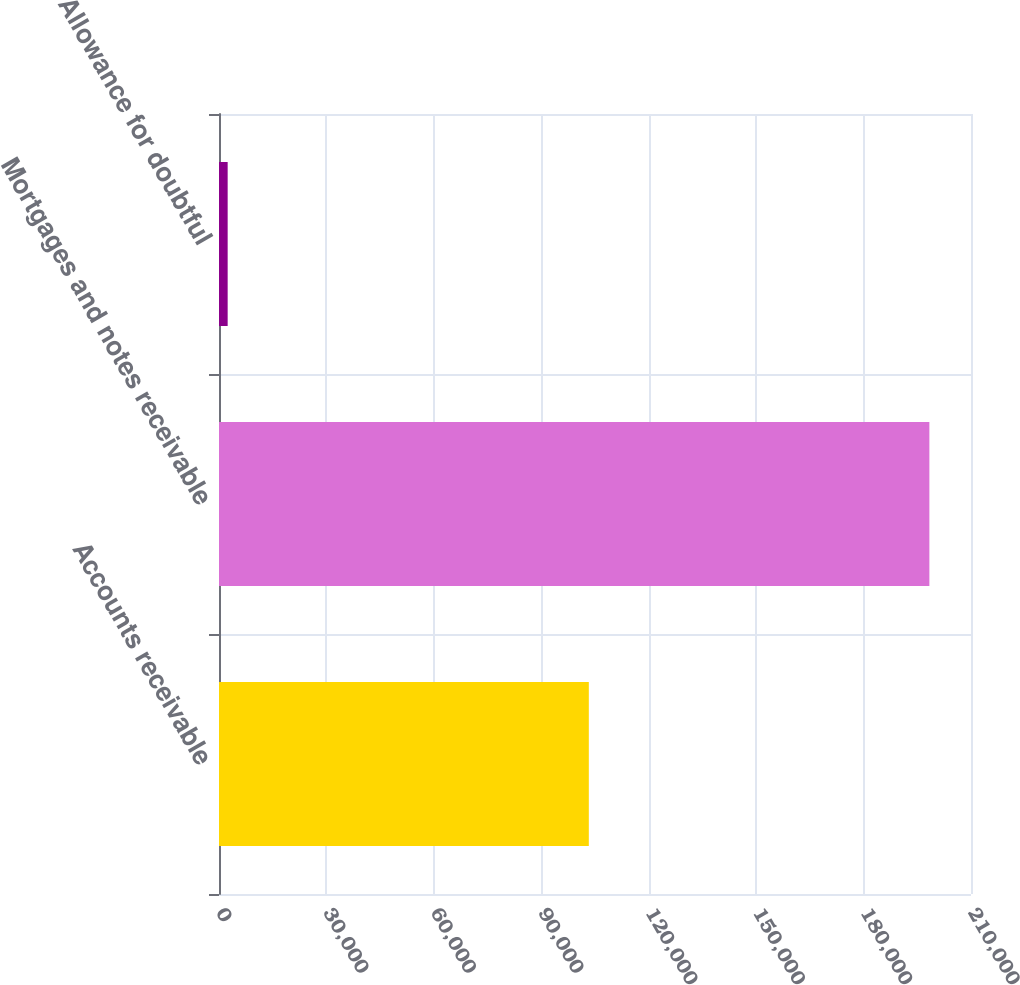<chart> <loc_0><loc_0><loc_500><loc_500><bar_chart><fcel>Accounts receivable<fcel>Mortgages and notes receivable<fcel>Allowance for doubtful<nl><fcel>103275<fcel>198376<fcel>2419<nl></chart> 